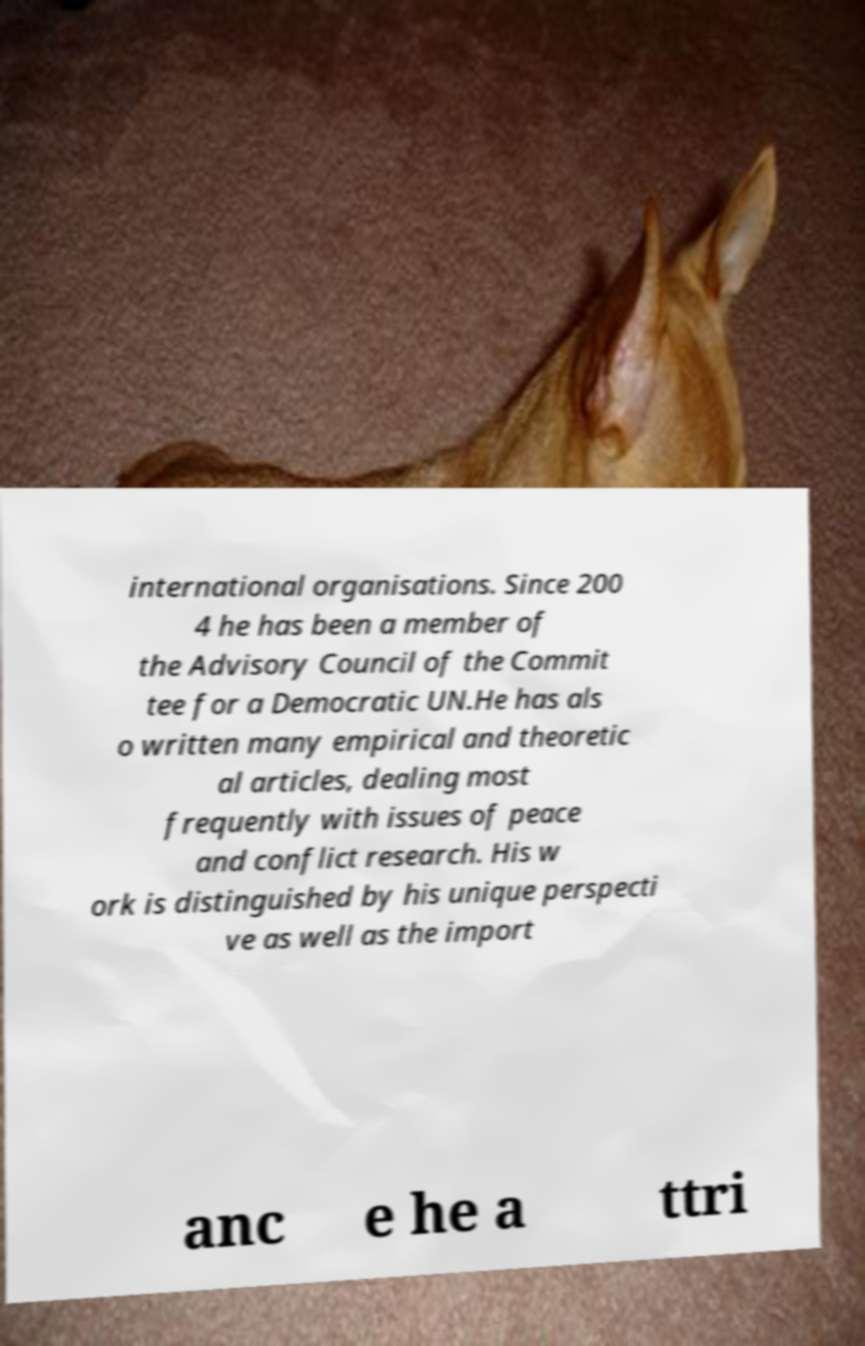There's text embedded in this image that I need extracted. Can you transcribe it verbatim? international organisations. Since 200 4 he has been a member of the Advisory Council of the Commit tee for a Democratic UN.He has als o written many empirical and theoretic al articles, dealing most frequently with issues of peace and conflict research. His w ork is distinguished by his unique perspecti ve as well as the import anc e he a ttri 